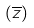Convert formula to latex. <formula><loc_0><loc_0><loc_500><loc_500>( \overline { z } )</formula> 